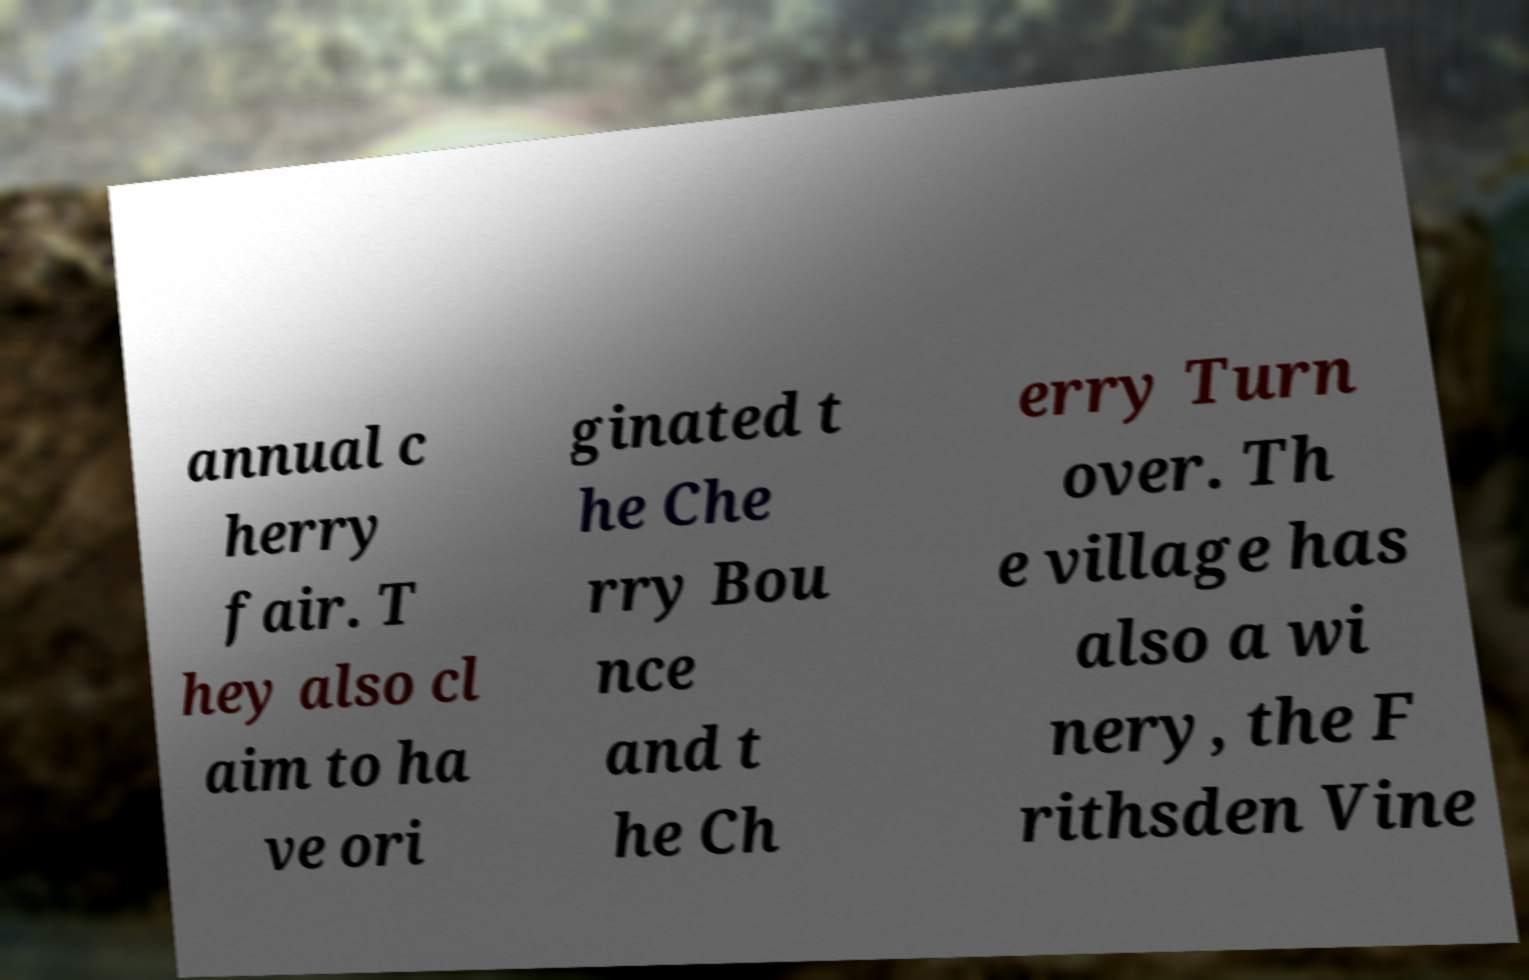Can you read and provide the text displayed in the image?This photo seems to have some interesting text. Can you extract and type it out for me? annual c herry fair. T hey also cl aim to ha ve ori ginated t he Che rry Bou nce and t he Ch erry Turn over. Th e village has also a wi nery, the F rithsden Vine 